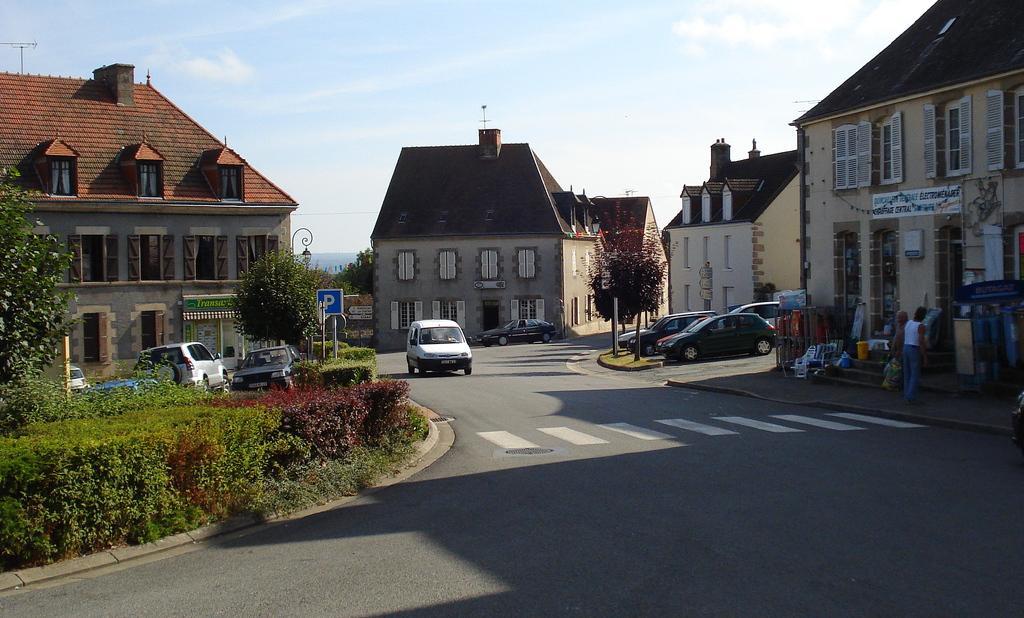Can you describe this image briefly? In this image we can see buildings, windows, there are plants, trees, there are poles, lights, there are two persons, some objects on the pavement, there are vehicles on the road, also we can see the sky. 